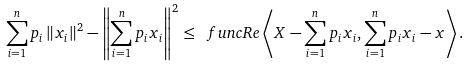<formula> <loc_0><loc_0><loc_500><loc_500>\sum _ { i = 1 } ^ { n } p _ { i } \left \| x _ { i } \right \| ^ { 2 } - \left \| \sum _ { i = 1 } ^ { n } p _ { i } x _ { i } \right \| ^ { 2 } \leq \ f u n c { R e } \left \langle X - \sum _ { i = 1 } ^ { n } p _ { i } x _ { i } , \sum _ { i = 1 } ^ { n } p _ { i } x _ { i } - x \right \rangle .</formula> 